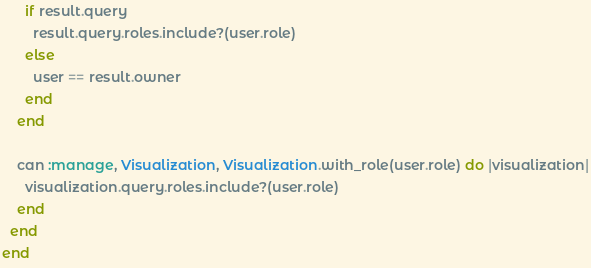<code> <loc_0><loc_0><loc_500><loc_500><_Ruby_>      if result.query
        result.query.roles.include?(user.role)
      else
        user == result.owner
      end
    end

    can :manage, Visualization, Visualization.with_role(user.role) do |visualization|
      visualization.query.roles.include?(user.role)
    end
  end
end
</code> 